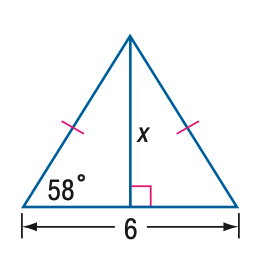Question: Find x. Round to the nearest tenth.
Choices:
A. 3.7
B. 4.8
C. 5.1
D. 6.0
Answer with the letter. Answer: B 